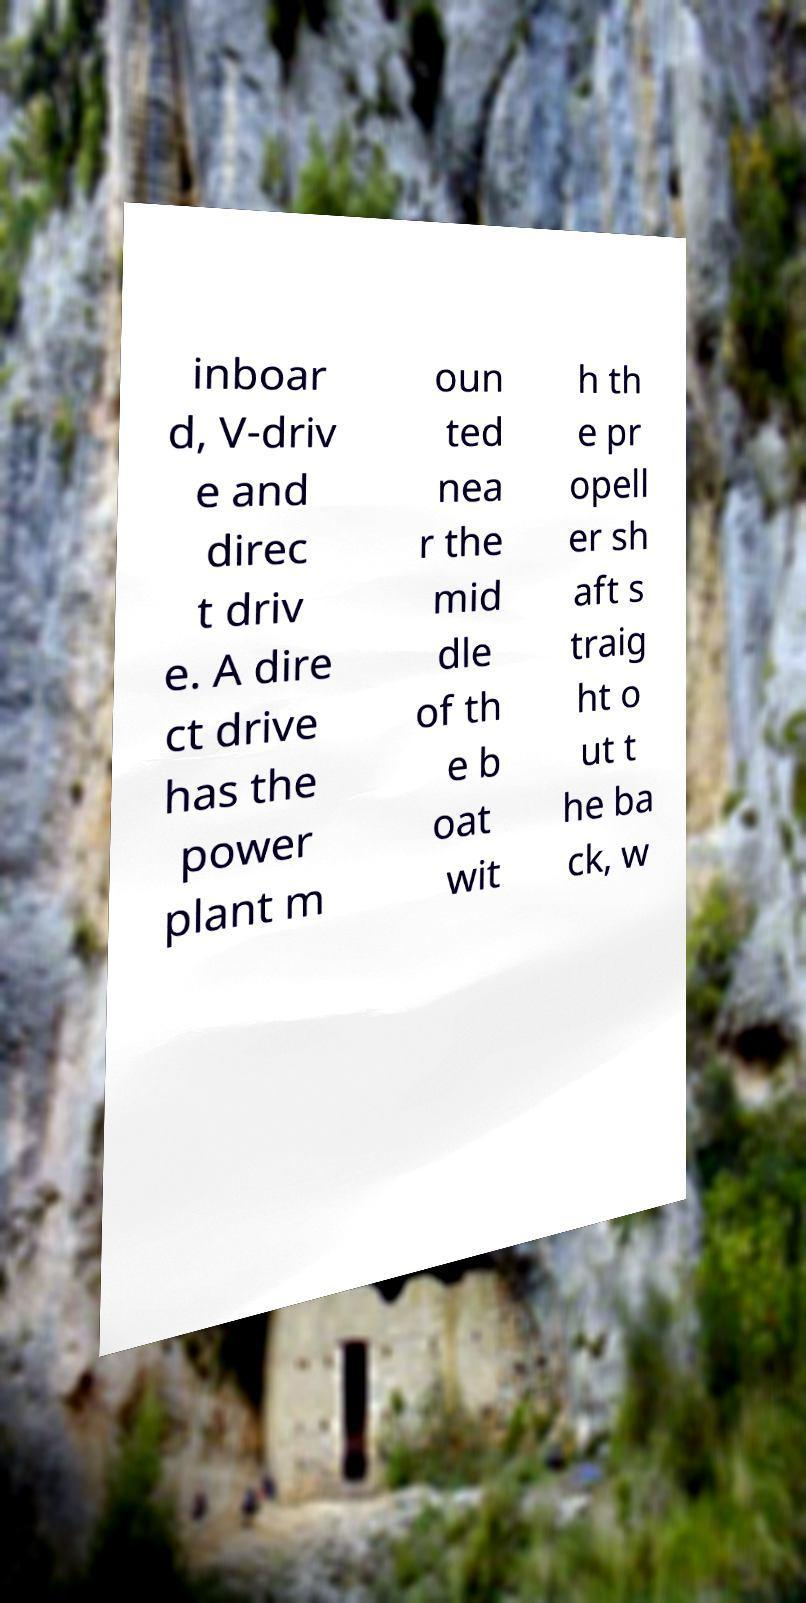For documentation purposes, I need the text within this image transcribed. Could you provide that? inboar d, V-driv e and direc t driv e. A dire ct drive has the power plant m oun ted nea r the mid dle of th e b oat wit h th e pr opell er sh aft s traig ht o ut t he ba ck, w 